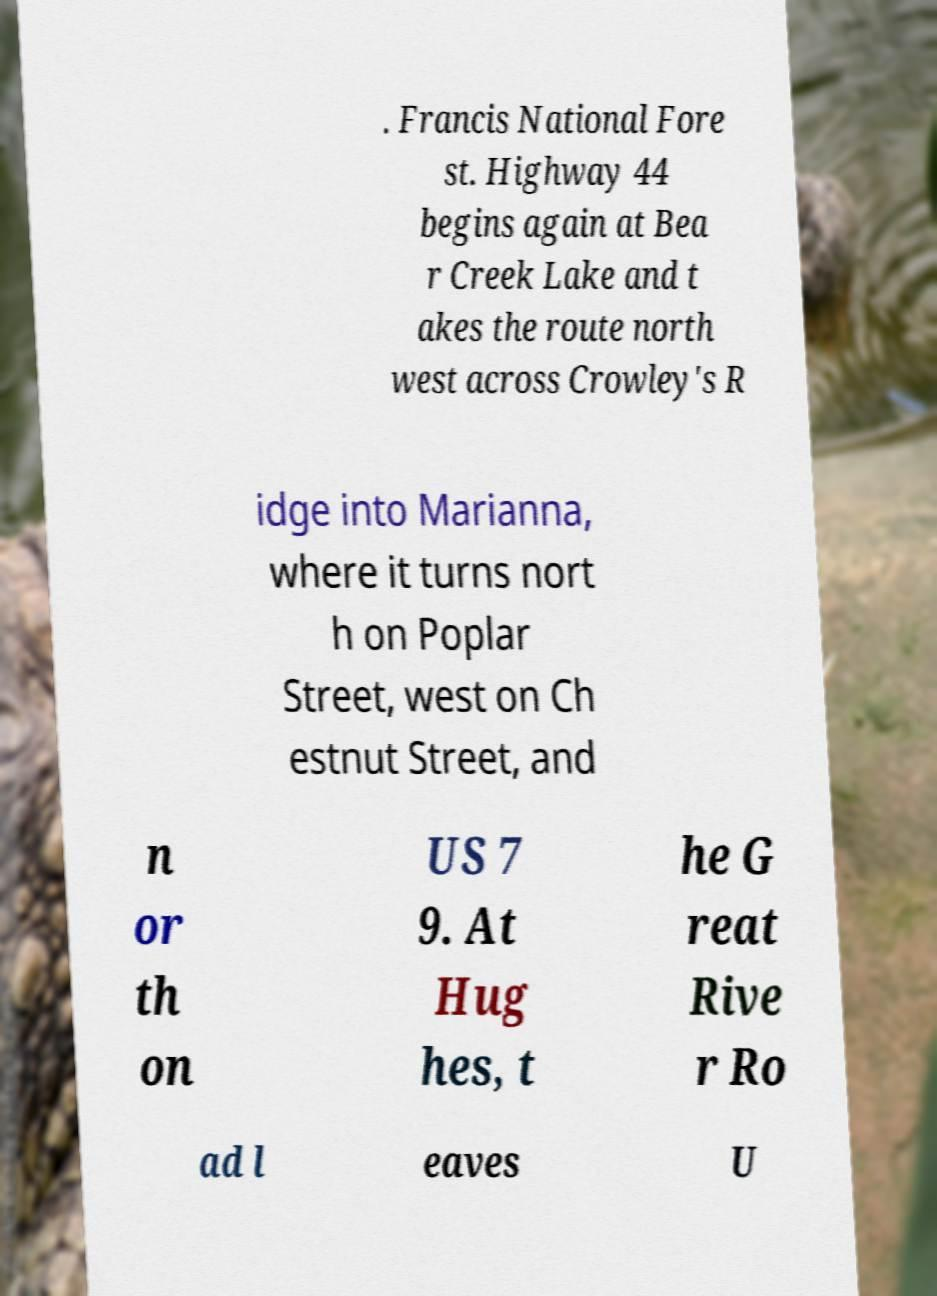What messages or text are displayed in this image? I need them in a readable, typed format. . Francis National Fore st. Highway 44 begins again at Bea r Creek Lake and t akes the route north west across Crowley's R idge into Marianna, where it turns nort h on Poplar Street, west on Ch estnut Street, and n or th on US 7 9. At Hug hes, t he G reat Rive r Ro ad l eaves U 